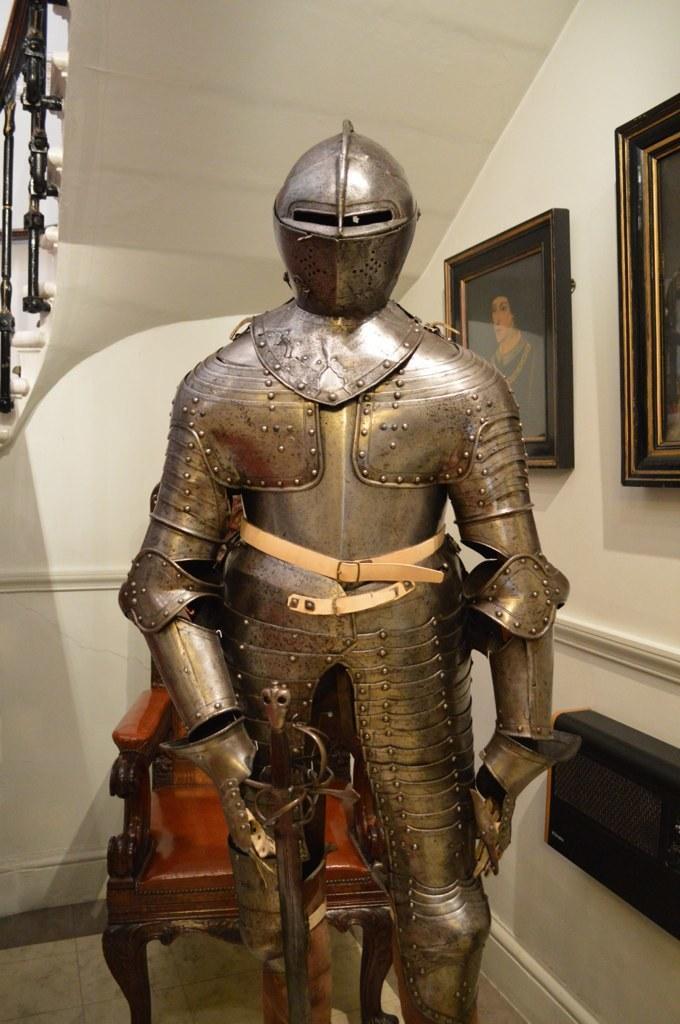Could you give a brief overview of what you see in this image? In this image we can see a statue with a breastplate, beside that we can see the chair, in the top left hand corner we can see the stairs. And on the right we can see photo frames on the wall, beside that we can see an object. 